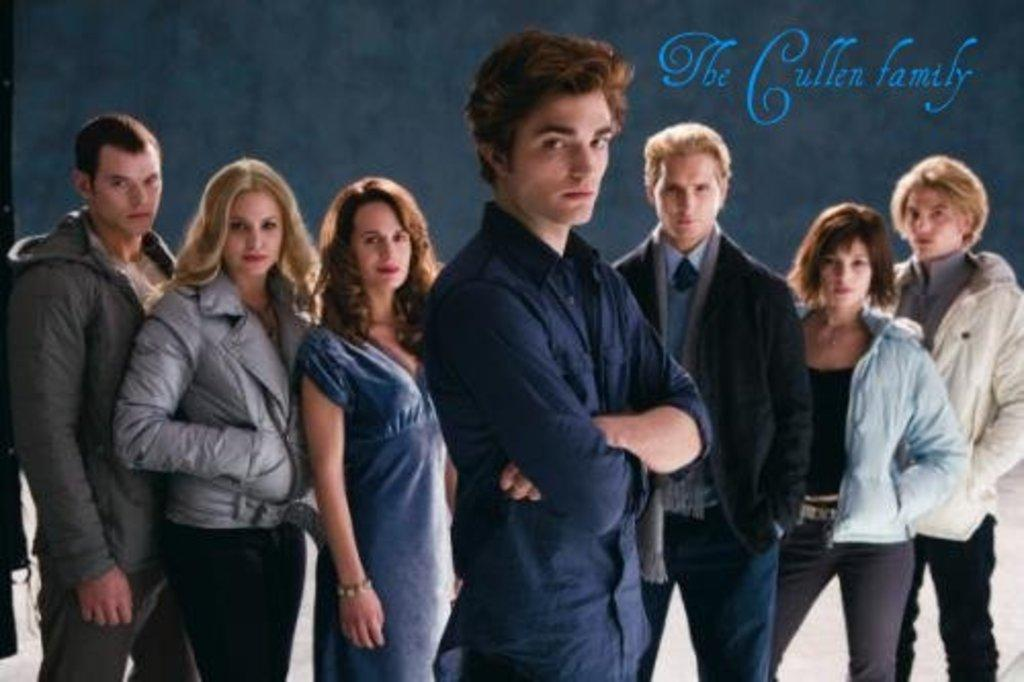How many people are in the image? There are a few persons standing in the image. What can be seen in the background of the image? There is a black color poster with some text in the background of the image. What type of exchange is happening between the persons in the image? There is no exchange happening between the persons in the image; they are simply standing. What is the desire of the persons in the image? There is no information about the desires of the persons in the image. 